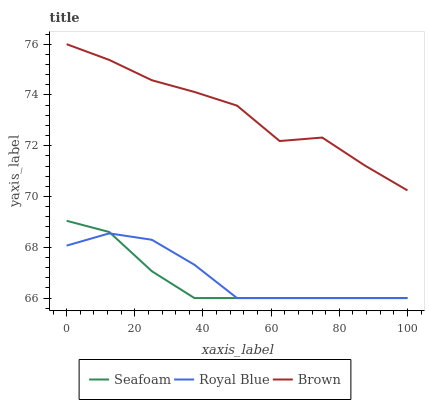Does Seafoam have the minimum area under the curve?
Answer yes or no. Yes. Does Brown have the maximum area under the curve?
Answer yes or no. Yes. Does Brown have the minimum area under the curve?
Answer yes or no. No. Does Seafoam have the maximum area under the curve?
Answer yes or no. No. Is Seafoam the smoothest?
Answer yes or no. Yes. Is Brown the roughest?
Answer yes or no. Yes. Is Brown the smoothest?
Answer yes or no. No. Is Seafoam the roughest?
Answer yes or no. No. Does Royal Blue have the lowest value?
Answer yes or no. Yes. Does Brown have the lowest value?
Answer yes or no. No. Does Brown have the highest value?
Answer yes or no. Yes. Does Seafoam have the highest value?
Answer yes or no. No. Is Seafoam less than Brown?
Answer yes or no. Yes. Is Brown greater than Royal Blue?
Answer yes or no. Yes. Does Seafoam intersect Royal Blue?
Answer yes or no. Yes. Is Seafoam less than Royal Blue?
Answer yes or no. No. Is Seafoam greater than Royal Blue?
Answer yes or no. No. Does Seafoam intersect Brown?
Answer yes or no. No. 